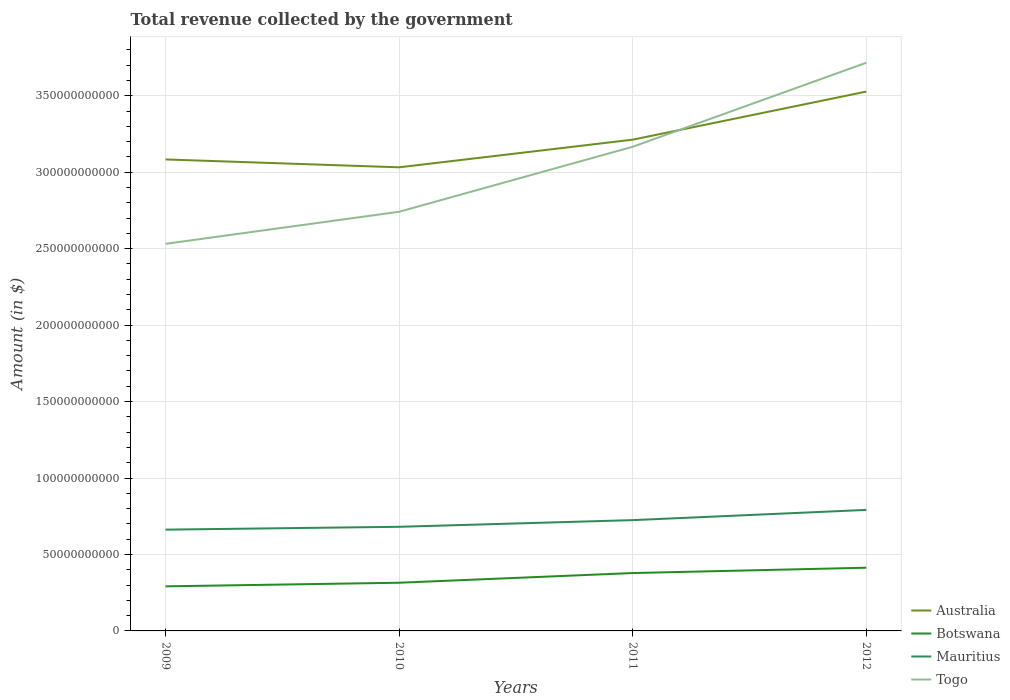Does the line corresponding to Togo intersect with the line corresponding to Mauritius?
Offer a terse response. No. Is the number of lines equal to the number of legend labels?
Provide a short and direct response. Yes. Across all years, what is the maximum total revenue collected by the government in Botswana?
Offer a very short reply. 2.92e+1. In which year was the total revenue collected by the government in Botswana maximum?
Make the answer very short. 2009. What is the total total revenue collected by the government in Togo in the graph?
Offer a terse response. -9.74e+1. What is the difference between the highest and the second highest total revenue collected by the government in Mauritius?
Ensure brevity in your answer.  1.29e+1. What is the difference between the highest and the lowest total revenue collected by the government in Botswana?
Your answer should be very brief. 2. Is the total revenue collected by the government in Australia strictly greater than the total revenue collected by the government in Togo over the years?
Keep it short and to the point. No. How many years are there in the graph?
Your answer should be very brief. 4. Does the graph contain grids?
Offer a very short reply. Yes. How many legend labels are there?
Your answer should be compact. 4. What is the title of the graph?
Your response must be concise. Total revenue collected by the government. Does "Spain" appear as one of the legend labels in the graph?
Provide a short and direct response. No. What is the label or title of the X-axis?
Make the answer very short. Years. What is the label or title of the Y-axis?
Keep it short and to the point. Amount (in $). What is the Amount (in $) in Australia in 2009?
Your answer should be very brief. 3.08e+11. What is the Amount (in $) of Botswana in 2009?
Your answer should be compact. 2.92e+1. What is the Amount (in $) in Mauritius in 2009?
Offer a very short reply. 6.62e+1. What is the Amount (in $) in Togo in 2009?
Provide a succinct answer. 2.53e+11. What is the Amount (in $) in Australia in 2010?
Offer a very short reply. 3.03e+11. What is the Amount (in $) in Botswana in 2010?
Provide a succinct answer. 3.15e+1. What is the Amount (in $) of Mauritius in 2010?
Your response must be concise. 6.81e+1. What is the Amount (in $) in Togo in 2010?
Provide a short and direct response. 2.74e+11. What is the Amount (in $) in Australia in 2011?
Your answer should be compact. 3.21e+11. What is the Amount (in $) in Botswana in 2011?
Give a very brief answer. 3.78e+1. What is the Amount (in $) of Mauritius in 2011?
Make the answer very short. 7.25e+1. What is the Amount (in $) of Togo in 2011?
Offer a terse response. 3.17e+11. What is the Amount (in $) in Australia in 2012?
Offer a terse response. 3.53e+11. What is the Amount (in $) in Botswana in 2012?
Ensure brevity in your answer.  4.13e+1. What is the Amount (in $) of Mauritius in 2012?
Give a very brief answer. 7.91e+1. What is the Amount (in $) of Togo in 2012?
Offer a very short reply. 3.72e+11. Across all years, what is the maximum Amount (in $) of Australia?
Provide a succinct answer. 3.53e+11. Across all years, what is the maximum Amount (in $) in Botswana?
Give a very brief answer. 4.13e+1. Across all years, what is the maximum Amount (in $) of Mauritius?
Provide a short and direct response. 7.91e+1. Across all years, what is the maximum Amount (in $) of Togo?
Your response must be concise. 3.72e+11. Across all years, what is the minimum Amount (in $) in Australia?
Offer a very short reply. 3.03e+11. Across all years, what is the minimum Amount (in $) in Botswana?
Your answer should be very brief. 2.92e+1. Across all years, what is the minimum Amount (in $) of Mauritius?
Provide a succinct answer. 6.62e+1. Across all years, what is the minimum Amount (in $) of Togo?
Offer a very short reply. 2.53e+11. What is the total Amount (in $) in Australia in the graph?
Offer a very short reply. 1.29e+12. What is the total Amount (in $) in Botswana in the graph?
Your response must be concise. 1.40e+11. What is the total Amount (in $) in Mauritius in the graph?
Your answer should be very brief. 2.86e+11. What is the total Amount (in $) of Togo in the graph?
Keep it short and to the point. 1.22e+12. What is the difference between the Amount (in $) in Australia in 2009 and that in 2010?
Provide a succinct answer. 5.14e+09. What is the difference between the Amount (in $) of Botswana in 2009 and that in 2010?
Your answer should be compact. -2.36e+09. What is the difference between the Amount (in $) of Mauritius in 2009 and that in 2010?
Provide a succinct answer. -1.85e+09. What is the difference between the Amount (in $) in Togo in 2009 and that in 2010?
Your response must be concise. -2.10e+1. What is the difference between the Amount (in $) in Australia in 2009 and that in 2011?
Offer a very short reply. -1.29e+1. What is the difference between the Amount (in $) in Botswana in 2009 and that in 2011?
Provide a short and direct response. -8.70e+09. What is the difference between the Amount (in $) of Mauritius in 2009 and that in 2011?
Your response must be concise. -6.22e+09. What is the difference between the Amount (in $) of Togo in 2009 and that in 2011?
Give a very brief answer. -6.35e+1. What is the difference between the Amount (in $) in Australia in 2009 and that in 2012?
Your response must be concise. -4.44e+1. What is the difference between the Amount (in $) in Botswana in 2009 and that in 2012?
Keep it short and to the point. -1.22e+1. What is the difference between the Amount (in $) in Mauritius in 2009 and that in 2012?
Your response must be concise. -1.29e+1. What is the difference between the Amount (in $) in Togo in 2009 and that in 2012?
Your response must be concise. -1.18e+11. What is the difference between the Amount (in $) in Australia in 2010 and that in 2011?
Provide a succinct answer. -1.81e+1. What is the difference between the Amount (in $) of Botswana in 2010 and that in 2011?
Your response must be concise. -6.34e+09. What is the difference between the Amount (in $) in Mauritius in 2010 and that in 2011?
Your answer should be very brief. -4.37e+09. What is the difference between the Amount (in $) in Togo in 2010 and that in 2011?
Keep it short and to the point. -4.25e+1. What is the difference between the Amount (in $) in Australia in 2010 and that in 2012?
Offer a very short reply. -4.95e+1. What is the difference between the Amount (in $) of Botswana in 2010 and that in 2012?
Provide a succinct answer. -9.83e+09. What is the difference between the Amount (in $) of Mauritius in 2010 and that in 2012?
Give a very brief answer. -1.10e+1. What is the difference between the Amount (in $) in Togo in 2010 and that in 2012?
Your answer should be compact. -9.74e+1. What is the difference between the Amount (in $) of Australia in 2011 and that in 2012?
Offer a terse response. -3.14e+1. What is the difference between the Amount (in $) in Botswana in 2011 and that in 2012?
Your answer should be very brief. -3.49e+09. What is the difference between the Amount (in $) of Mauritius in 2011 and that in 2012?
Make the answer very short. -6.68e+09. What is the difference between the Amount (in $) in Togo in 2011 and that in 2012?
Your answer should be very brief. -5.49e+1. What is the difference between the Amount (in $) in Australia in 2009 and the Amount (in $) in Botswana in 2010?
Provide a succinct answer. 2.77e+11. What is the difference between the Amount (in $) in Australia in 2009 and the Amount (in $) in Mauritius in 2010?
Give a very brief answer. 2.40e+11. What is the difference between the Amount (in $) in Australia in 2009 and the Amount (in $) in Togo in 2010?
Your response must be concise. 3.42e+1. What is the difference between the Amount (in $) of Botswana in 2009 and the Amount (in $) of Mauritius in 2010?
Your answer should be very brief. -3.89e+1. What is the difference between the Amount (in $) of Botswana in 2009 and the Amount (in $) of Togo in 2010?
Ensure brevity in your answer.  -2.45e+11. What is the difference between the Amount (in $) of Mauritius in 2009 and the Amount (in $) of Togo in 2010?
Keep it short and to the point. -2.08e+11. What is the difference between the Amount (in $) in Australia in 2009 and the Amount (in $) in Botswana in 2011?
Your answer should be very brief. 2.70e+11. What is the difference between the Amount (in $) in Australia in 2009 and the Amount (in $) in Mauritius in 2011?
Ensure brevity in your answer.  2.36e+11. What is the difference between the Amount (in $) of Australia in 2009 and the Amount (in $) of Togo in 2011?
Give a very brief answer. -8.29e+09. What is the difference between the Amount (in $) of Botswana in 2009 and the Amount (in $) of Mauritius in 2011?
Your answer should be compact. -4.33e+1. What is the difference between the Amount (in $) of Botswana in 2009 and the Amount (in $) of Togo in 2011?
Ensure brevity in your answer.  -2.87e+11. What is the difference between the Amount (in $) of Mauritius in 2009 and the Amount (in $) of Togo in 2011?
Give a very brief answer. -2.50e+11. What is the difference between the Amount (in $) in Australia in 2009 and the Amount (in $) in Botswana in 2012?
Provide a short and direct response. 2.67e+11. What is the difference between the Amount (in $) of Australia in 2009 and the Amount (in $) of Mauritius in 2012?
Offer a very short reply. 2.29e+11. What is the difference between the Amount (in $) in Australia in 2009 and the Amount (in $) in Togo in 2012?
Give a very brief answer. -6.32e+1. What is the difference between the Amount (in $) in Botswana in 2009 and the Amount (in $) in Mauritius in 2012?
Provide a short and direct response. -5.00e+1. What is the difference between the Amount (in $) in Botswana in 2009 and the Amount (in $) in Togo in 2012?
Make the answer very short. -3.42e+11. What is the difference between the Amount (in $) in Mauritius in 2009 and the Amount (in $) in Togo in 2012?
Provide a short and direct response. -3.05e+11. What is the difference between the Amount (in $) of Australia in 2010 and the Amount (in $) of Botswana in 2011?
Your answer should be compact. 2.65e+11. What is the difference between the Amount (in $) in Australia in 2010 and the Amount (in $) in Mauritius in 2011?
Provide a short and direct response. 2.31e+11. What is the difference between the Amount (in $) in Australia in 2010 and the Amount (in $) in Togo in 2011?
Keep it short and to the point. -1.34e+1. What is the difference between the Amount (in $) of Botswana in 2010 and the Amount (in $) of Mauritius in 2011?
Keep it short and to the point. -4.10e+1. What is the difference between the Amount (in $) in Botswana in 2010 and the Amount (in $) in Togo in 2011?
Offer a very short reply. -2.85e+11. What is the difference between the Amount (in $) of Mauritius in 2010 and the Amount (in $) of Togo in 2011?
Provide a succinct answer. -2.49e+11. What is the difference between the Amount (in $) of Australia in 2010 and the Amount (in $) of Botswana in 2012?
Your response must be concise. 2.62e+11. What is the difference between the Amount (in $) of Australia in 2010 and the Amount (in $) of Mauritius in 2012?
Offer a terse response. 2.24e+11. What is the difference between the Amount (in $) of Australia in 2010 and the Amount (in $) of Togo in 2012?
Offer a terse response. -6.84e+1. What is the difference between the Amount (in $) in Botswana in 2010 and the Amount (in $) in Mauritius in 2012?
Make the answer very short. -4.76e+1. What is the difference between the Amount (in $) of Botswana in 2010 and the Amount (in $) of Togo in 2012?
Ensure brevity in your answer.  -3.40e+11. What is the difference between the Amount (in $) of Mauritius in 2010 and the Amount (in $) of Togo in 2012?
Offer a very short reply. -3.03e+11. What is the difference between the Amount (in $) of Australia in 2011 and the Amount (in $) of Botswana in 2012?
Make the answer very short. 2.80e+11. What is the difference between the Amount (in $) in Australia in 2011 and the Amount (in $) in Mauritius in 2012?
Offer a terse response. 2.42e+11. What is the difference between the Amount (in $) in Australia in 2011 and the Amount (in $) in Togo in 2012?
Provide a short and direct response. -5.03e+1. What is the difference between the Amount (in $) in Botswana in 2011 and the Amount (in $) in Mauritius in 2012?
Provide a short and direct response. -4.13e+1. What is the difference between the Amount (in $) in Botswana in 2011 and the Amount (in $) in Togo in 2012?
Keep it short and to the point. -3.34e+11. What is the difference between the Amount (in $) in Mauritius in 2011 and the Amount (in $) in Togo in 2012?
Ensure brevity in your answer.  -2.99e+11. What is the average Amount (in $) of Australia per year?
Your answer should be very brief. 3.21e+11. What is the average Amount (in $) in Botswana per year?
Offer a very short reply. 3.50e+1. What is the average Amount (in $) in Mauritius per year?
Provide a short and direct response. 7.15e+1. What is the average Amount (in $) of Togo per year?
Your response must be concise. 3.04e+11. In the year 2009, what is the difference between the Amount (in $) in Australia and Amount (in $) in Botswana?
Give a very brief answer. 2.79e+11. In the year 2009, what is the difference between the Amount (in $) in Australia and Amount (in $) in Mauritius?
Keep it short and to the point. 2.42e+11. In the year 2009, what is the difference between the Amount (in $) of Australia and Amount (in $) of Togo?
Your answer should be compact. 5.52e+1. In the year 2009, what is the difference between the Amount (in $) of Botswana and Amount (in $) of Mauritius?
Your response must be concise. -3.71e+1. In the year 2009, what is the difference between the Amount (in $) of Botswana and Amount (in $) of Togo?
Ensure brevity in your answer.  -2.24e+11. In the year 2009, what is the difference between the Amount (in $) of Mauritius and Amount (in $) of Togo?
Provide a succinct answer. -1.87e+11. In the year 2010, what is the difference between the Amount (in $) in Australia and Amount (in $) in Botswana?
Your response must be concise. 2.72e+11. In the year 2010, what is the difference between the Amount (in $) of Australia and Amount (in $) of Mauritius?
Ensure brevity in your answer.  2.35e+11. In the year 2010, what is the difference between the Amount (in $) in Australia and Amount (in $) in Togo?
Offer a very short reply. 2.91e+1. In the year 2010, what is the difference between the Amount (in $) of Botswana and Amount (in $) of Mauritius?
Make the answer very short. -3.66e+1. In the year 2010, what is the difference between the Amount (in $) in Botswana and Amount (in $) in Togo?
Your answer should be compact. -2.43e+11. In the year 2010, what is the difference between the Amount (in $) of Mauritius and Amount (in $) of Togo?
Offer a terse response. -2.06e+11. In the year 2011, what is the difference between the Amount (in $) of Australia and Amount (in $) of Botswana?
Your response must be concise. 2.83e+11. In the year 2011, what is the difference between the Amount (in $) in Australia and Amount (in $) in Mauritius?
Provide a short and direct response. 2.49e+11. In the year 2011, what is the difference between the Amount (in $) in Australia and Amount (in $) in Togo?
Make the answer very short. 4.64e+09. In the year 2011, what is the difference between the Amount (in $) in Botswana and Amount (in $) in Mauritius?
Your answer should be very brief. -3.46e+1. In the year 2011, what is the difference between the Amount (in $) of Botswana and Amount (in $) of Togo?
Make the answer very short. -2.79e+11. In the year 2011, what is the difference between the Amount (in $) of Mauritius and Amount (in $) of Togo?
Your answer should be very brief. -2.44e+11. In the year 2012, what is the difference between the Amount (in $) in Australia and Amount (in $) in Botswana?
Offer a terse response. 3.11e+11. In the year 2012, what is the difference between the Amount (in $) in Australia and Amount (in $) in Mauritius?
Keep it short and to the point. 2.74e+11. In the year 2012, what is the difference between the Amount (in $) of Australia and Amount (in $) of Togo?
Your response must be concise. -1.89e+1. In the year 2012, what is the difference between the Amount (in $) in Botswana and Amount (in $) in Mauritius?
Your answer should be very brief. -3.78e+1. In the year 2012, what is the difference between the Amount (in $) in Botswana and Amount (in $) in Togo?
Your answer should be very brief. -3.30e+11. In the year 2012, what is the difference between the Amount (in $) of Mauritius and Amount (in $) of Togo?
Your answer should be compact. -2.92e+11. What is the ratio of the Amount (in $) of Australia in 2009 to that in 2010?
Give a very brief answer. 1.02. What is the ratio of the Amount (in $) in Botswana in 2009 to that in 2010?
Ensure brevity in your answer.  0.93. What is the ratio of the Amount (in $) of Mauritius in 2009 to that in 2010?
Offer a terse response. 0.97. What is the ratio of the Amount (in $) of Togo in 2009 to that in 2010?
Give a very brief answer. 0.92. What is the ratio of the Amount (in $) of Australia in 2009 to that in 2011?
Make the answer very short. 0.96. What is the ratio of the Amount (in $) of Botswana in 2009 to that in 2011?
Offer a very short reply. 0.77. What is the ratio of the Amount (in $) of Mauritius in 2009 to that in 2011?
Your response must be concise. 0.91. What is the ratio of the Amount (in $) of Togo in 2009 to that in 2011?
Provide a succinct answer. 0.8. What is the ratio of the Amount (in $) of Australia in 2009 to that in 2012?
Give a very brief answer. 0.87. What is the ratio of the Amount (in $) in Botswana in 2009 to that in 2012?
Make the answer very short. 0.71. What is the ratio of the Amount (in $) in Mauritius in 2009 to that in 2012?
Ensure brevity in your answer.  0.84. What is the ratio of the Amount (in $) in Togo in 2009 to that in 2012?
Your response must be concise. 0.68. What is the ratio of the Amount (in $) in Australia in 2010 to that in 2011?
Make the answer very short. 0.94. What is the ratio of the Amount (in $) in Botswana in 2010 to that in 2011?
Offer a terse response. 0.83. What is the ratio of the Amount (in $) of Mauritius in 2010 to that in 2011?
Keep it short and to the point. 0.94. What is the ratio of the Amount (in $) in Togo in 2010 to that in 2011?
Give a very brief answer. 0.87. What is the ratio of the Amount (in $) in Australia in 2010 to that in 2012?
Keep it short and to the point. 0.86. What is the ratio of the Amount (in $) of Botswana in 2010 to that in 2012?
Offer a terse response. 0.76. What is the ratio of the Amount (in $) of Mauritius in 2010 to that in 2012?
Ensure brevity in your answer.  0.86. What is the ratio of the Amount (in $) in Togo in 2010 to that in 2012?
Keep it short and to the point. 0.74. What is the ratio of the Amount (in $) in Australia in 2011 to that in 2012?
Your response must be concise. 0.91. What is the ratio of the Amount (in $) in Botswana in 2011 to that in 2012?
Offer a terse response. 0.92. What is the ratio of the Amount (in $) in Mauritius in 2011 to that in 2012?
Keep it short and to the point. 0.92. What is the ratio of the Amount (in $) of Togo in 2011 to that in 2012?
Make the answer very short. 0.85. What is the difference between the highest and the second highest Amount (in $) in Australia?
Give a very brief answer. 3.14e+1. What is the difference between the highest and the second highest Amount (in $) in Botswana?
Your response must be concise. 3.49e+09. What is the difference between the highest and the second highest Amount (in $) in Mauritius?
Keep it short and to the point. 6.68e+09. What is the difference between the highest and the second highest Amount (in $) of Togo?
Your answer should be compact. 5.49e+1. What is the difference between the highest and the lowest Amount (in $) of Australia?
Your answer should be compact. 4.95e+1. What is the difference between the highest and the lowest Amount (in $) in Botswana?
Make the answer very short. 1.22e+1. What is the difference between the highest and the lowest Amount (in $) of Mauritius?
Your answer should be very brief. 1.29e+1. What is the difference between the highest and the lowest Amount (in $) of Togo?
Offer a terse response. 1.18e+11. 